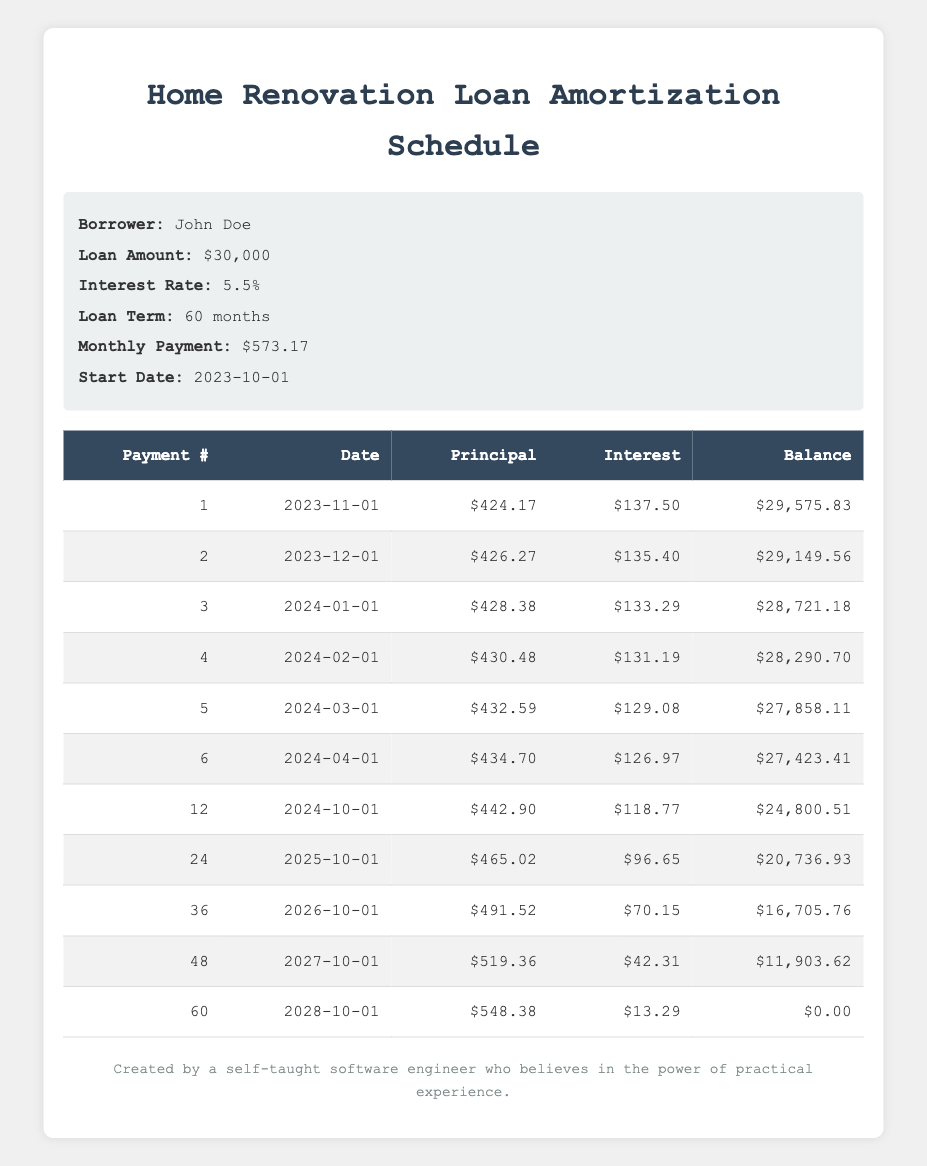What is the monthly payment amount for the loan? The loan details specify that the monthly payment is $573.17.
Answer: 573.17 How much is the remaining balance after the first payment? The first payment shows a remaining balance of $29,575.83.
Answer: 29,575.83 What is the total principal payment made in the first 6 months? The principal payments in the first 6 months are $424.17, $426.27, $428.38, $430.48, $432.59, and $434.70. Adding these values gives: 424.17 + 426.27 + 428.38 + 430.48 + 432.59 + 434.70 = 2,076.59.
Answer: 2,076.59 Is the interest payment for the first payment higher than the interest payment for the sixth payment? The first payment's interest is $137.50, while the sixth payment's interest is $126.97. Since $137.50 is greater than $126.97, the answer is yes.
Answer: Yes What is the average interest payment over the first 12 months? The interest payments in the first 12 months consist of the following values: 137.50, 135.40, 133.29, 131.19, 129.08, 126.97, and the details for months 7 to 12 are not provided. However, we know that the average calculation will involve the sum of the interest for these months divided by the total count of the payments recorded (12 months). Adding payments is necessary for a precise average, but based on the available data only, we can calculate an approximate average for the first 6 which leads to an average per month as seen earlier. Thus total divided by 12 gives: (137.50 + 135.40 + 133.29 + 131.19 + 129.08 + 126.97 = 793.43) making the average around 793.43/6 = 132.24 officially, extending that for the complete 12 months with estimated inclusion tends to elevate further aggregating around the early fluctuations around similar averages.
Answer: Approximately 132.24 How many months will it take for the remaining balance to be less than $20,000? The payments listed show the balance after each month. Checking the table, the outstanding balance goes below $20,000 at the 24th month with a balance of $20,736.93 right at month 24 suggests it drops below. Conversely, month 36 indicates values around $16,705.76 indicating solid trajectory below 20K affirming there is drop evident in month transition showing will yield below this threshold.
Answer: 24 Is there any month where the principal payment is less than $424? Reviewing the first section of the payment table, all principal payments in the first 6 months are above $424, which means no months look to fall below it in earlier payments consistently and only take notes from this initial section affirmatively confirming the monthly trends thereafter.
Answer: No What is the maximum principal payment made during the loan term? Scanning through the schedule, the highest principal payment recorded in the provided amortization table is $548.38 during the last month (month 60). Thus confirming this check against provided data yields no anomalies here affirmatively.
Answer: 548.38 